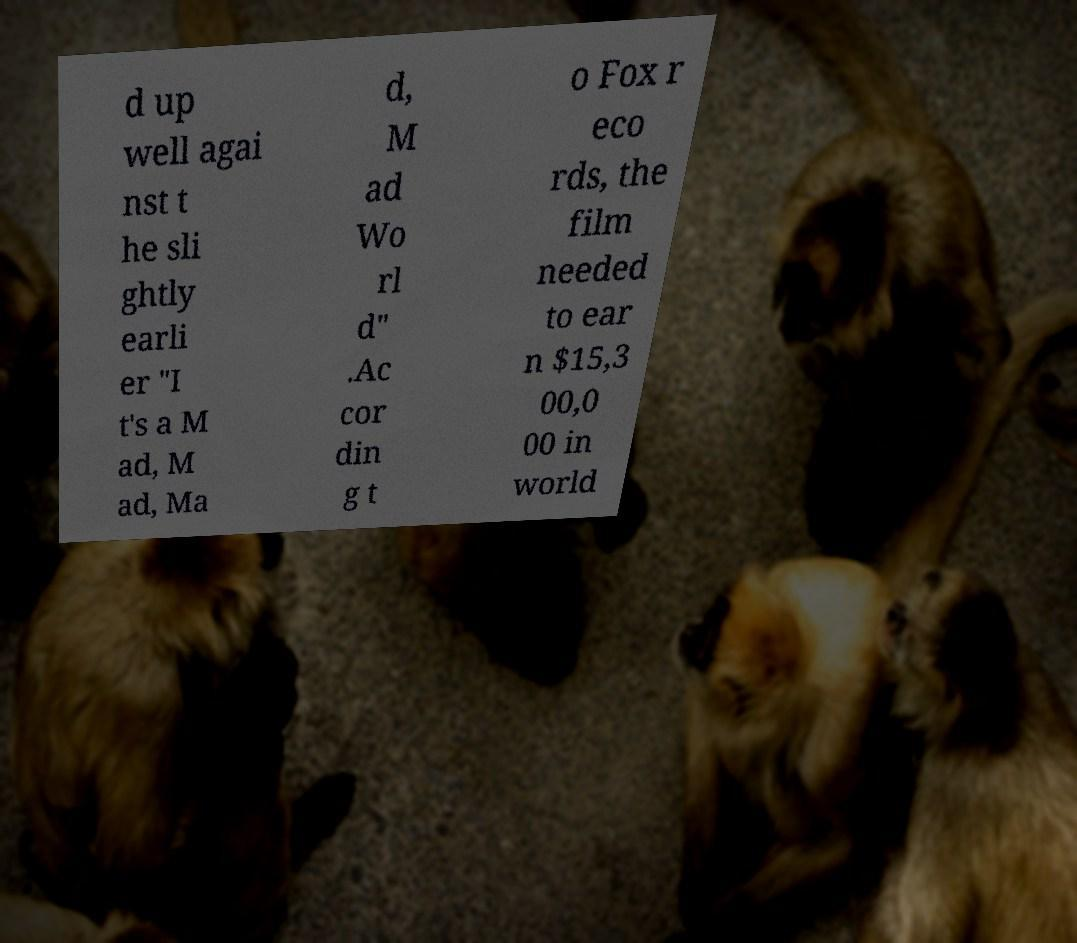Could you assist in decoding the text presented in this image and type it out clearly? d up well agai nst t he sli ghtly earli er "I t's a M ad, M ad, Ma d, M ad Wo rl d" .Ac cor din g t o Fox r eco rds, the film needed to ear n $15,3 00,0 00 in world 